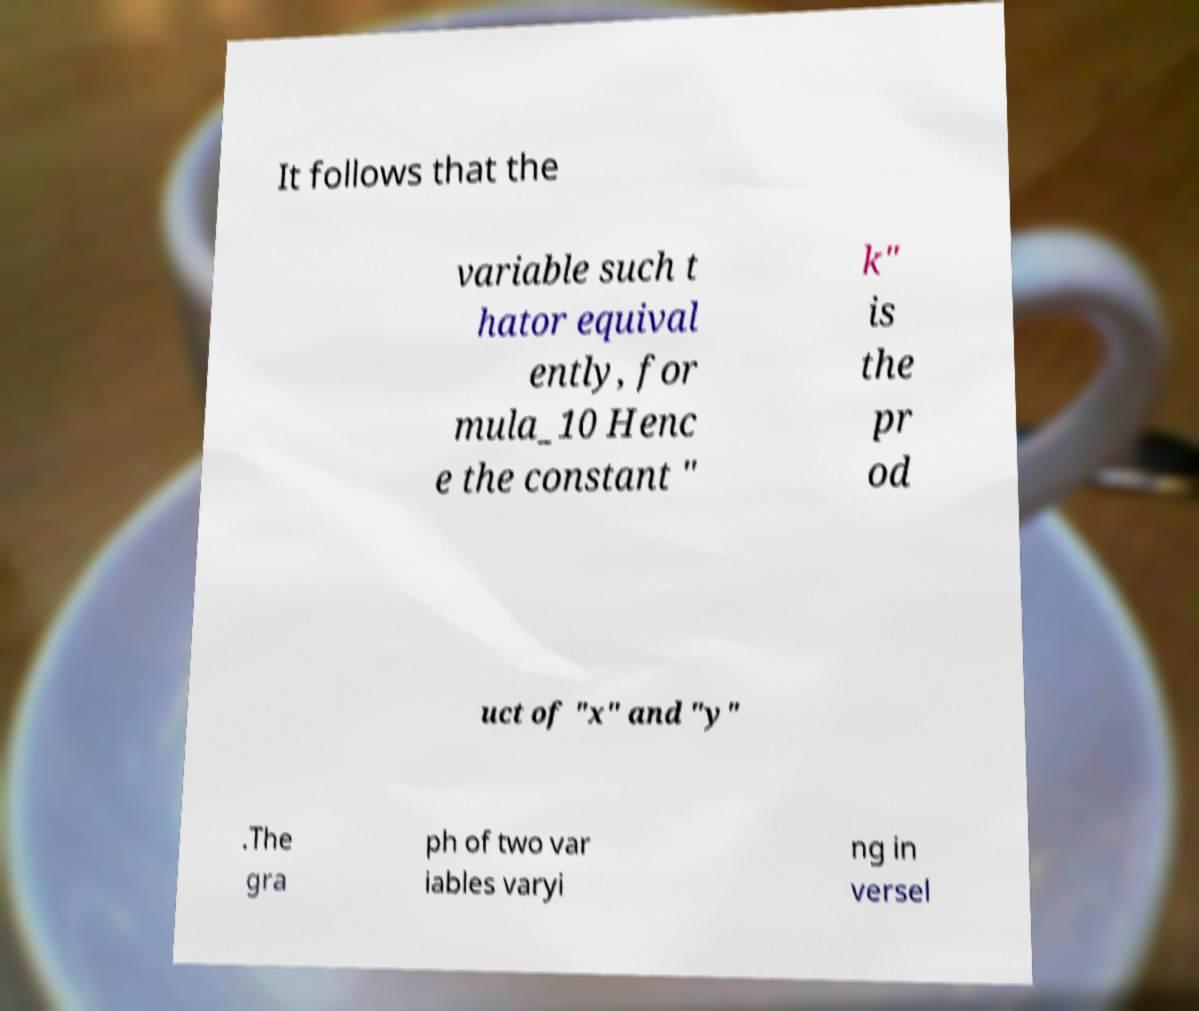Please read and relay the text visible in this image. What does it say? It follows that the variable such t hator equival ently, for mula_10 Henc e the constant " k" is the pr od uct of "x" and "y" .The gra ph of two var iables varyi ng in versel 